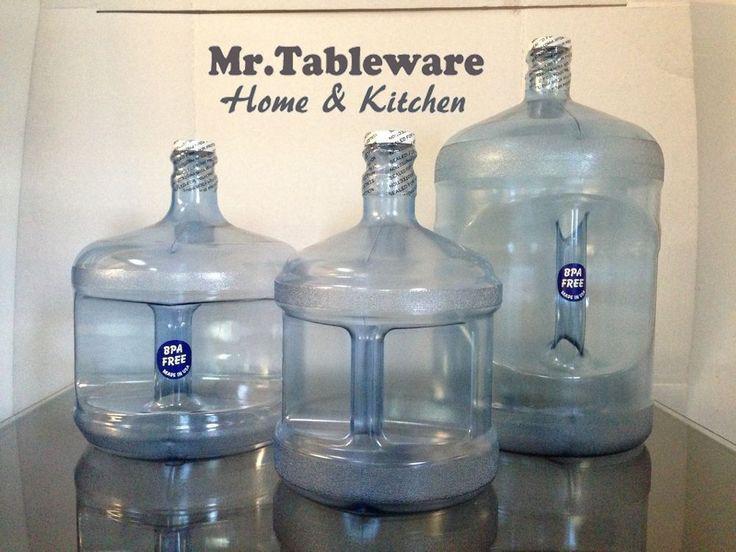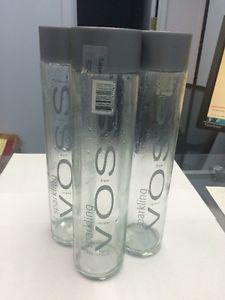The first image is the image on the left, the second image is the image on the right. Considering the images on both sides, is "None of the bottles have labels." valid? Answer yes or no. No. The first image is the image on the left, the second image is the image on the right. Considering the images on both sides, is "In one image, three empty bottles with no caps and glistening from a light source, are sitting in a triangle shaped arrangement." valid? Answer yes or no. No. 